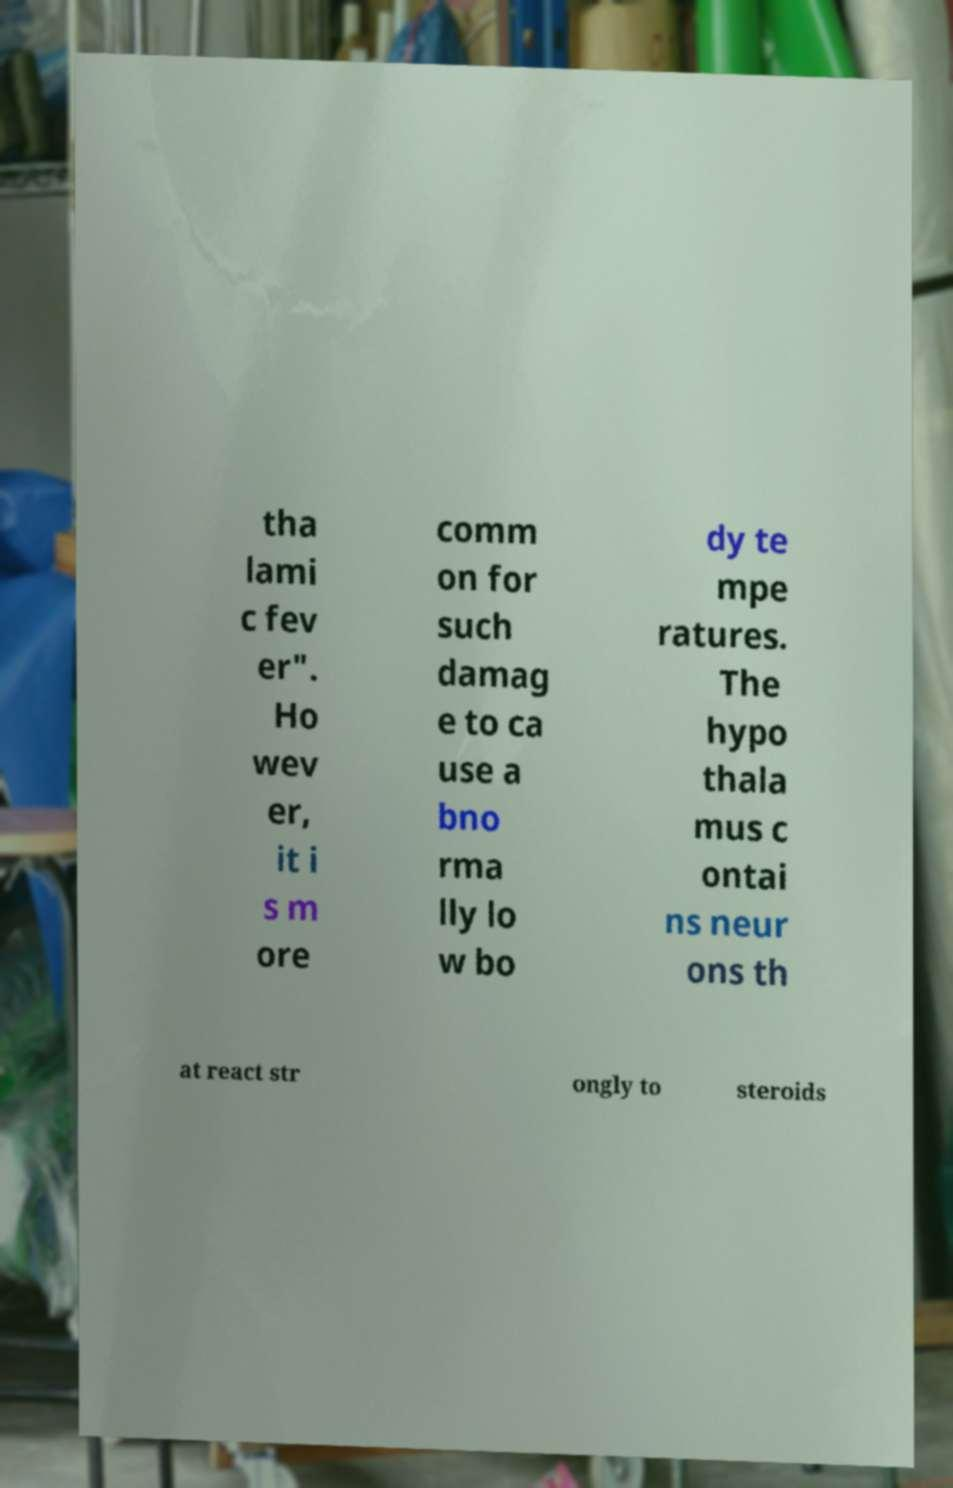Can you accurately transcribe the text from the provided image for me? tha lami c fev er". Ho wev er, it i s m ore comm on for such damag e to ca use a bno rma lly lo w bo dy te mpe ratures. The hypo thala mus c ontai ns neur ons th at react str ongly to steroids 